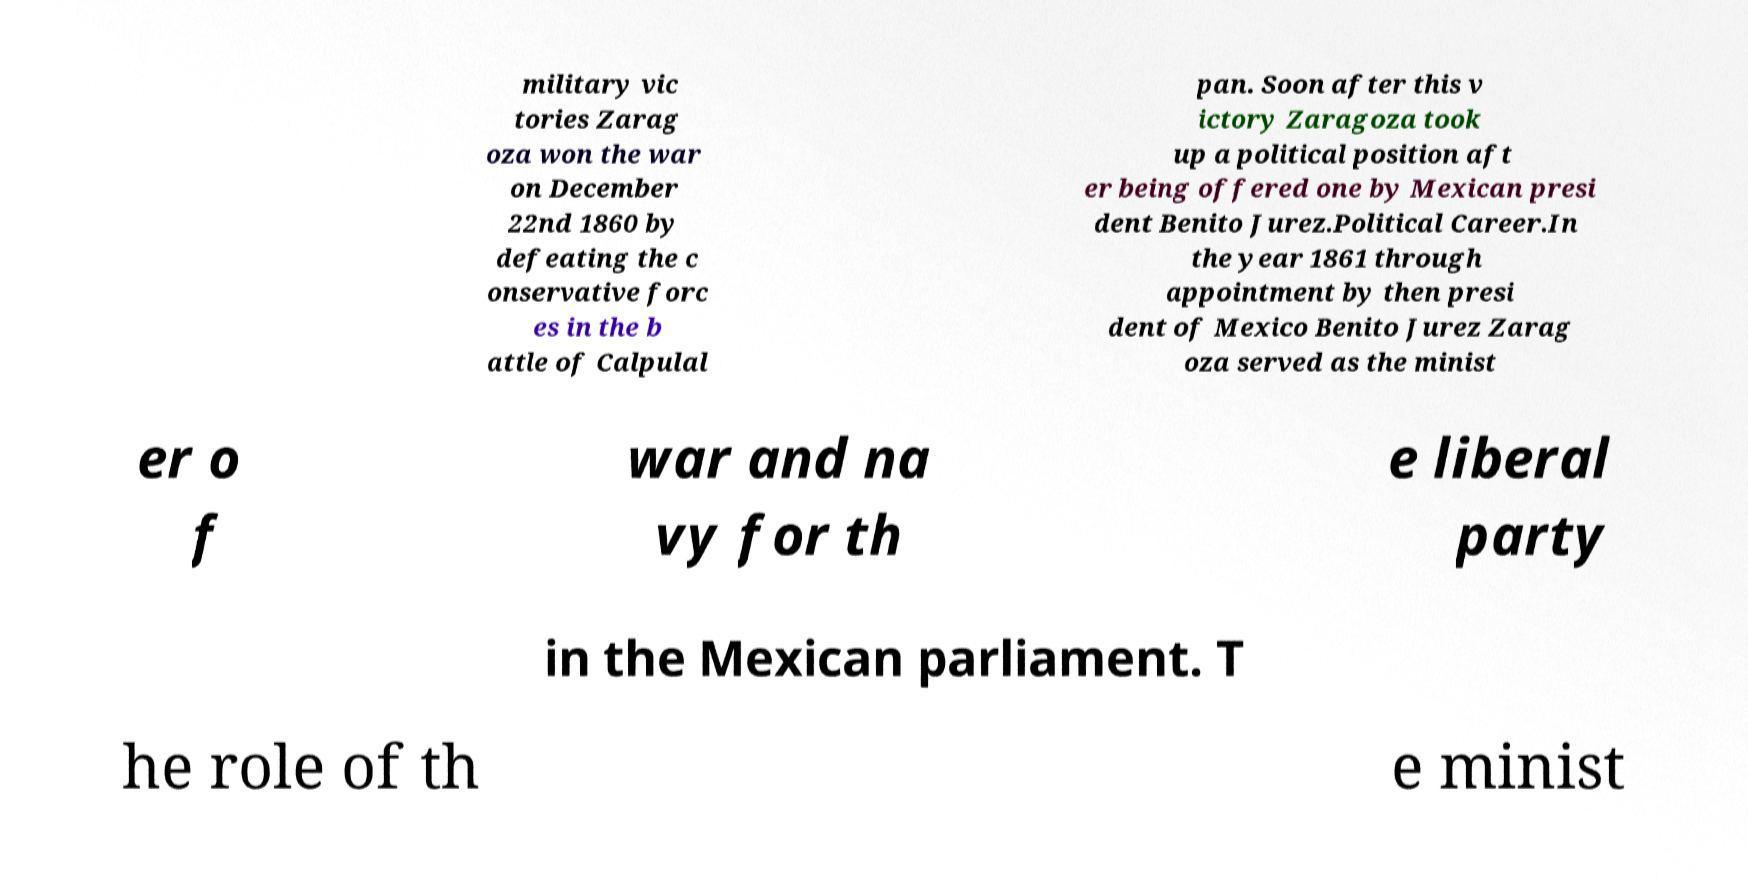Can you read and provide the text displayed in the image?This photo seems to have some interesting text. Can you extract and type it out for me? military vic tories Zarag oza won the war on December 22nd 1860 by defeating the c onservative forc es in the b attle of Calpulal pan. Soon after this v ictory Zaragoza took up a political position aft er being offered one by Mexican presi dent Benito Jurez.Political Career.In the year 1861 through appointment by then presi dent of Mexico Benito Jurez Zarag oza served as the minist er o f war and na vy for th e liberal party in the Mexican parliament. T he role of th e minist 